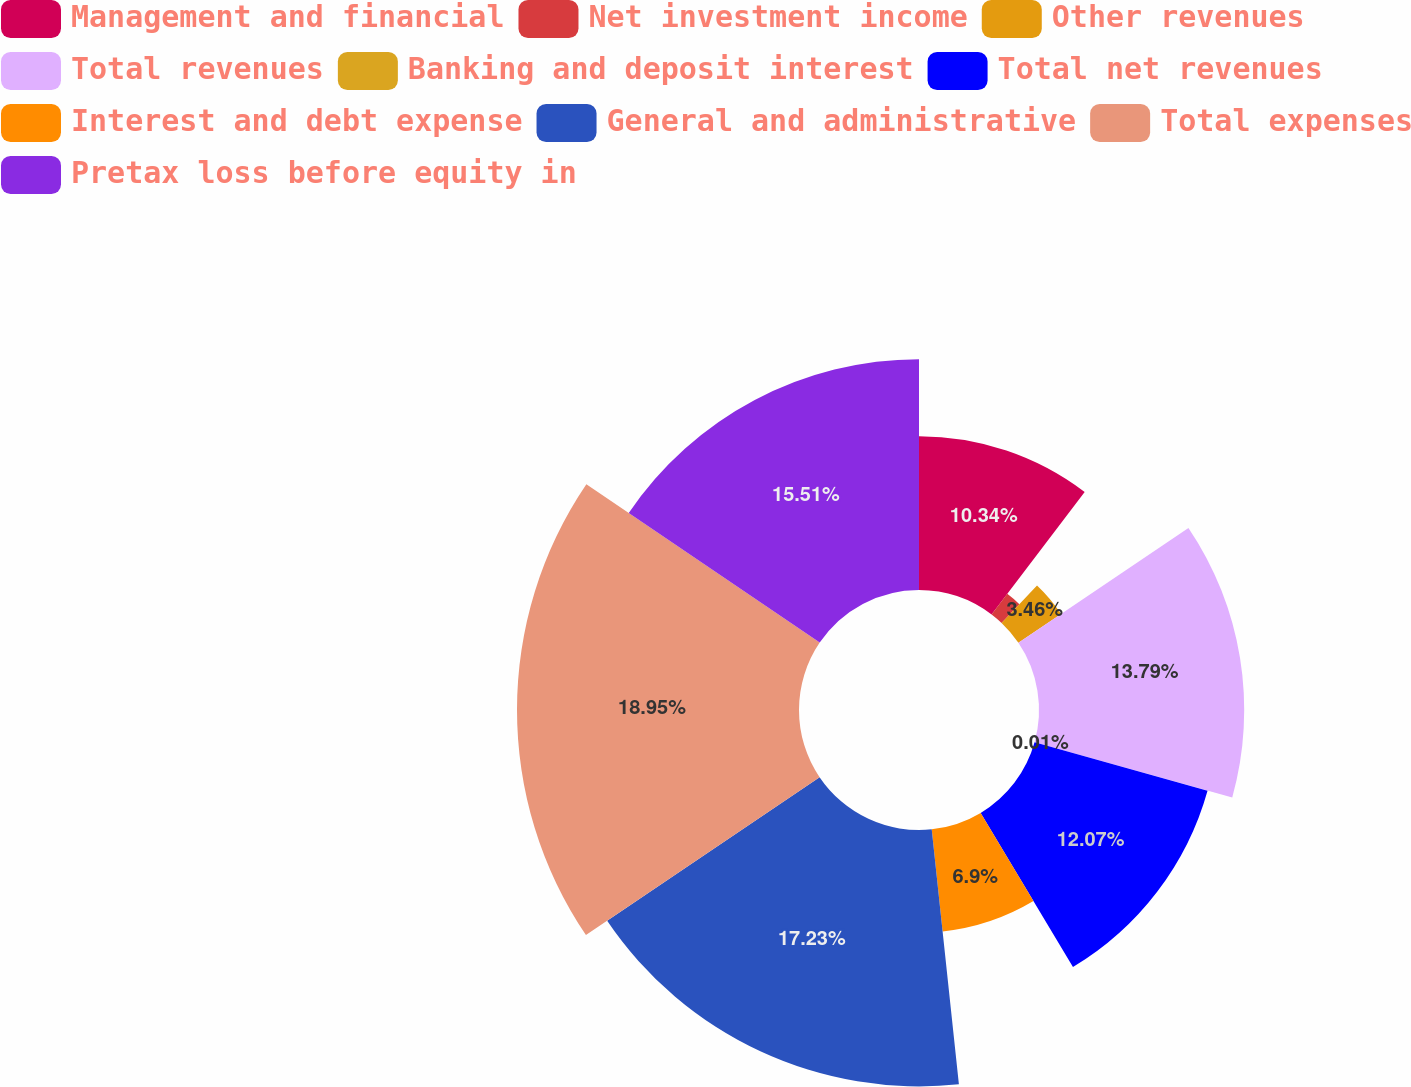<chart> <loc_0><loc_0><loc_500><loc_500><pie_chart><fcel>Management and financial<fcel>Net investment income<fcel>Other revenues<fcel>Total revenues<fcel>Banking and deposit interest<fcel>Total net revenues<fcel>Interest and debt expense<fcel>General and administrative<fcel>Total expenses<fcel>Pretax loss before equity in<nl><fcel>10.34%<fcel>1.74%<fcel>3.46%<fcel>13.79%<fcel>0.01%<fcel>12.07%<fcel>6.9%<fcel>17.23%<fcel>18.95%<fcel>15.51%<nl></chart> 